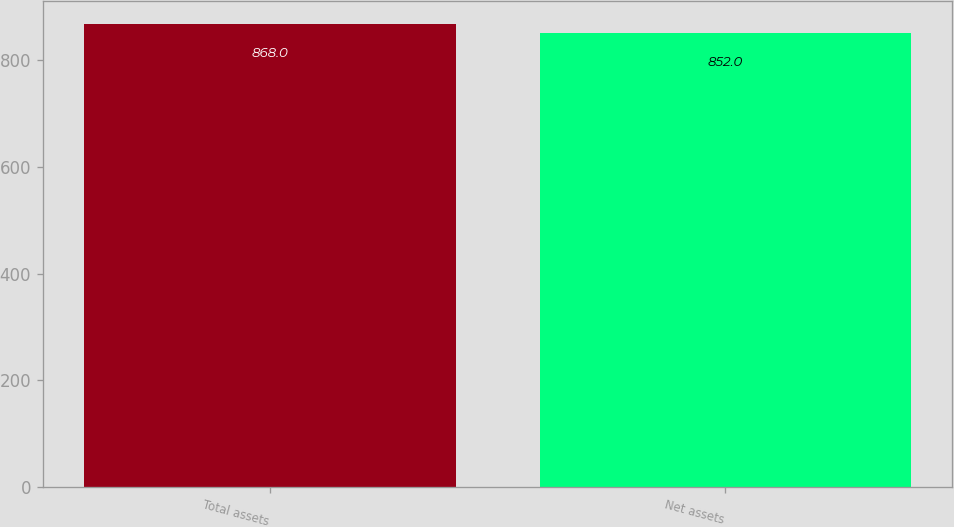<chart> <loc_0><loc_0><loc_500><loc_500><bar_chart><fcel>Total assets<fcel>Net assets<nl><fcel>868<fcel>852<nl></chart> 